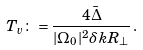Convert formula to latex. <formula><loc_0><loc_0><loc_500><loc_500>T _ { v } \colon = \frac { 4 \bar { \Delta } } { | \Omega _ { 0 } | ^ { 2 } \delta k R _ { \perp } } \, .</formula> 